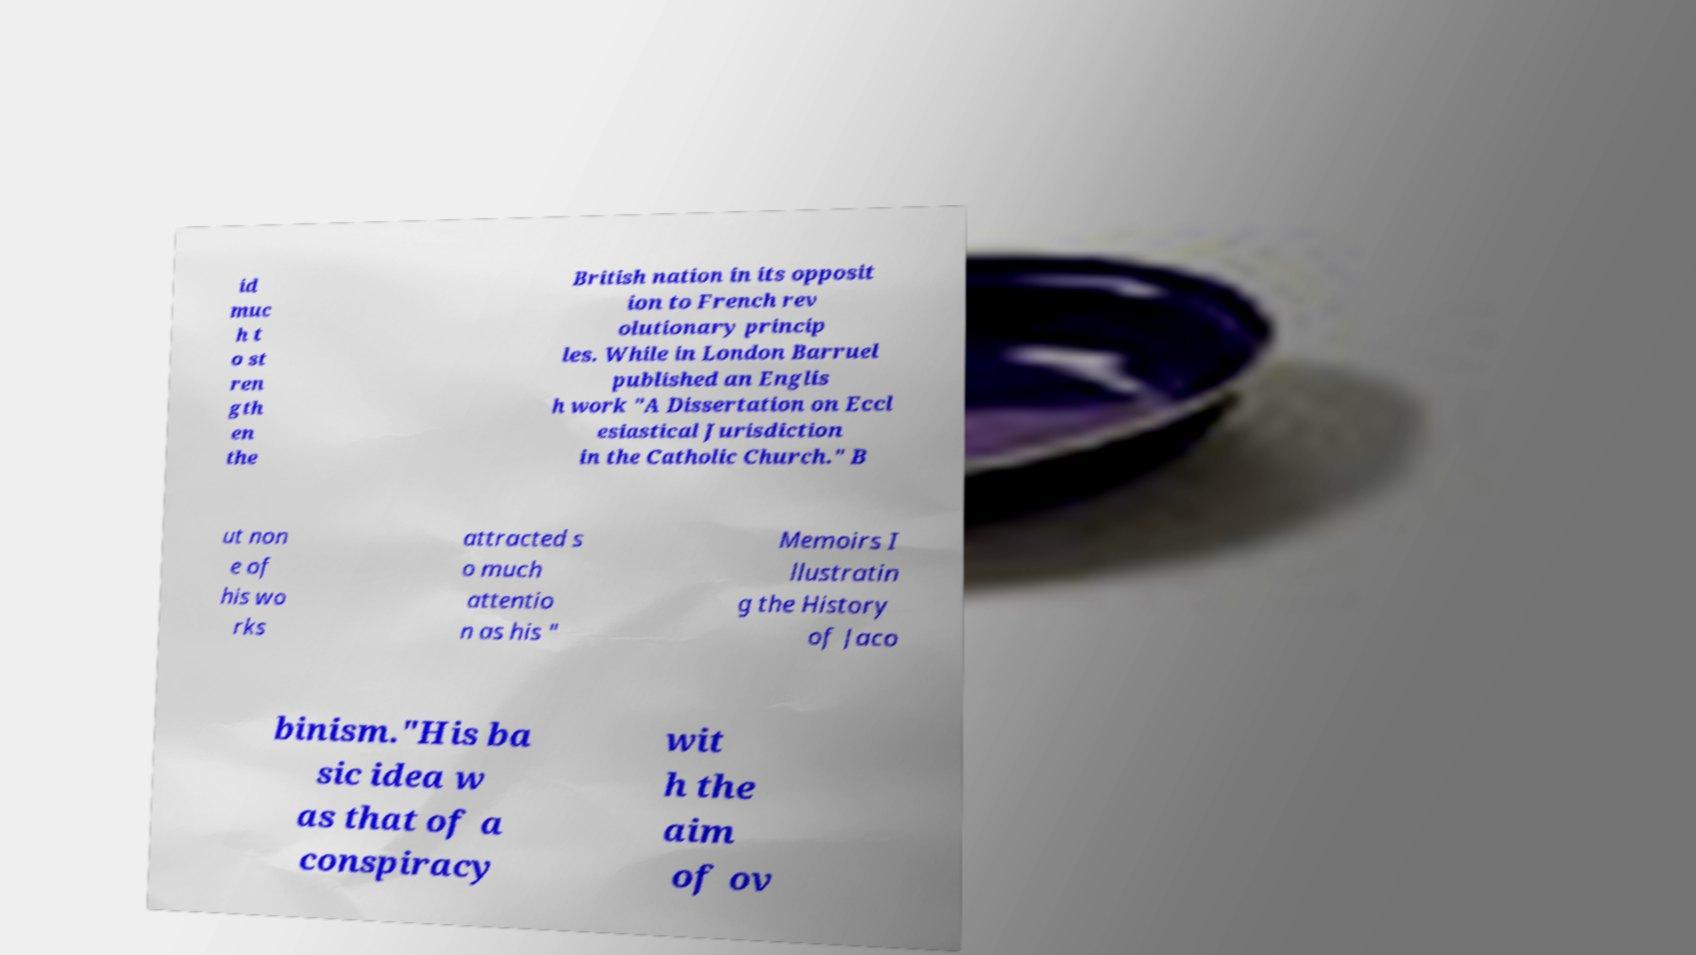For documentation purposes, I need the text within this image transcribed. Could you provide that? id muc h t o st ren gth en the British nation in its opposit ion to French rev olutionary princip les. While in London Barruel published an Englis h work "A Dissertation on Eccl esiastical Jurisdiction in the Catholic Church." B ut non e of his wo rks attracted s o much attentio n as his " Memoirs I llustratin g the History of Jaco binism."His ba sic idea w as that of a conspiracy wit h the aim of ov 